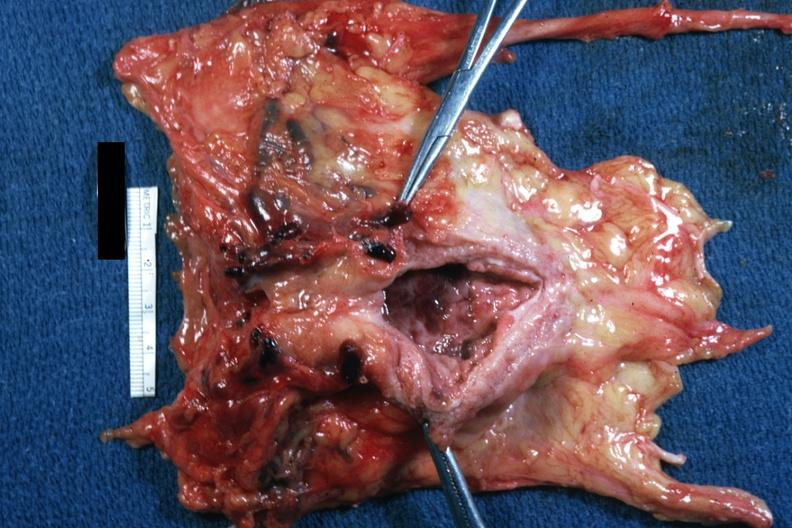what does this image show?
Answer the question using a single word or phrase. Numerous large thrombi 